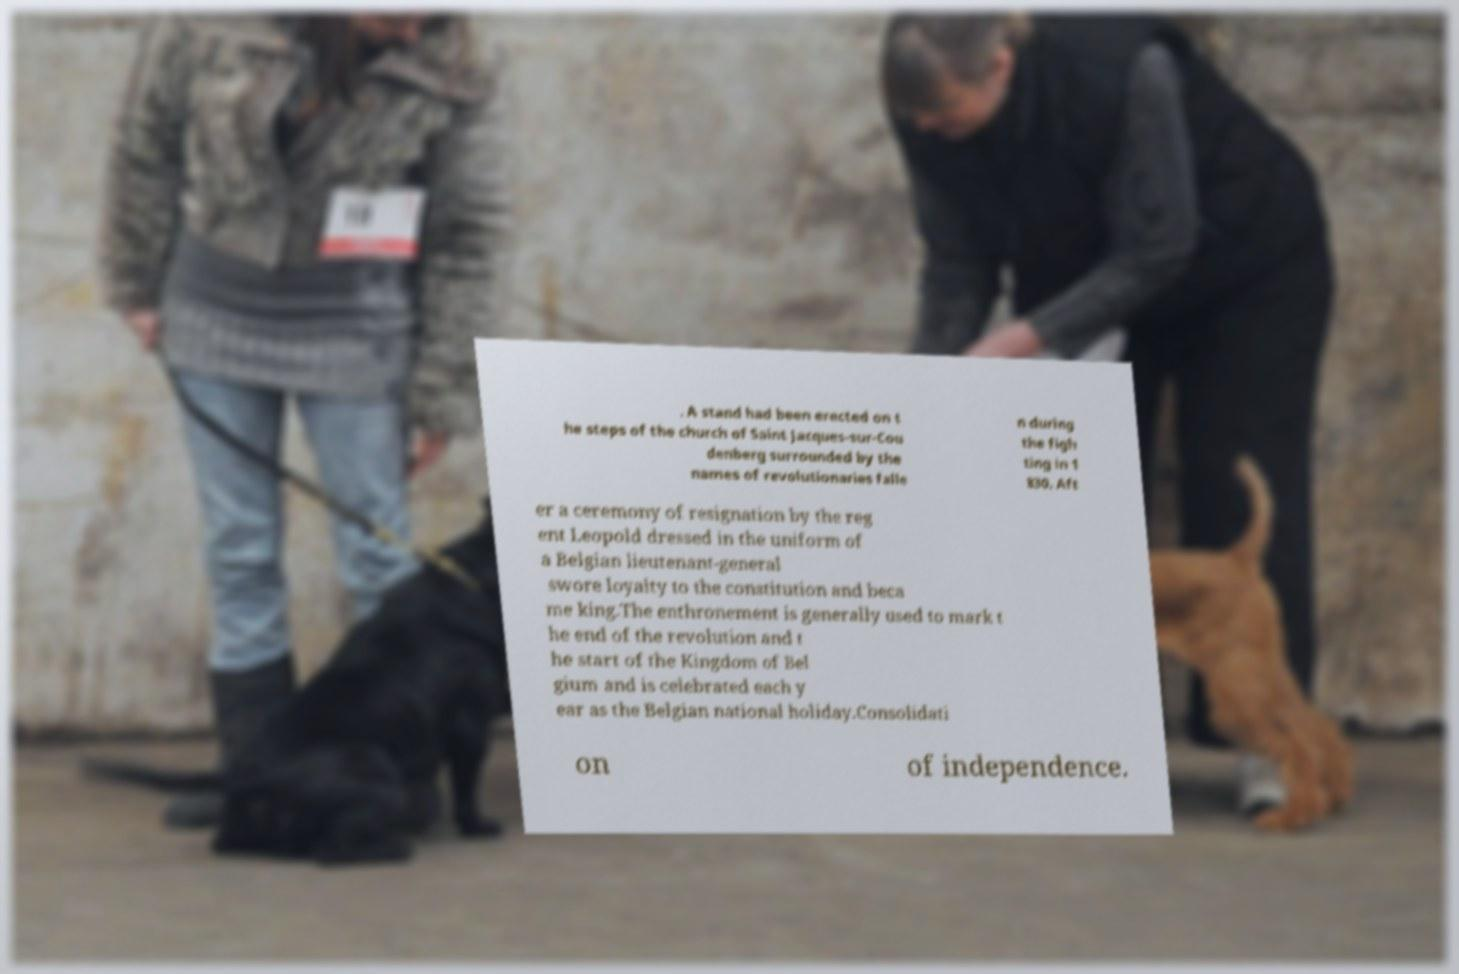Please identify and transcribe the text found in this image. . A stand had been erected on t he steps of the church of Saint Jacques-sur-Cou denberg surrounded by the names of revolutionaries falle n during the figh ting in 1 830. Aft er a ceremony of resignation by the reg ent Leopold dressed in the uniform of a Belgian lieutenant-general swore loyalty to the constitution and beca me king.The enthronement is generally used to mark t he end of the revolution and t he start of the Kingdom of Bel gium and is celebrated each y ear as the Belgian national holiday.Consolidati on of independence. 